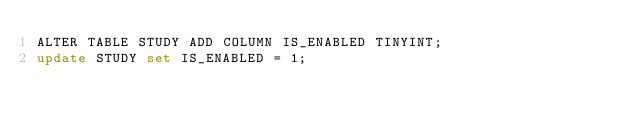Convert code to text. <code><loc_0><loc_0><loc_500><loc_500><_SQL_>ALTER TABLE STUDY ADD COLUMN IS_ENABLED TINYINT;
update STUDY set IS_ENABLED = 1;</code> 